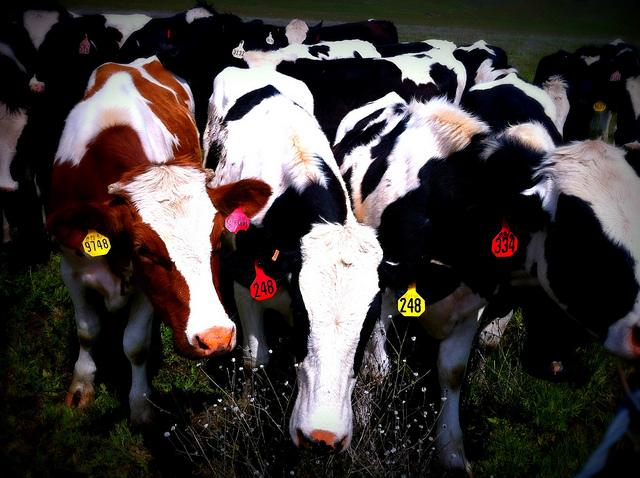What animals have the tags on them? cows 